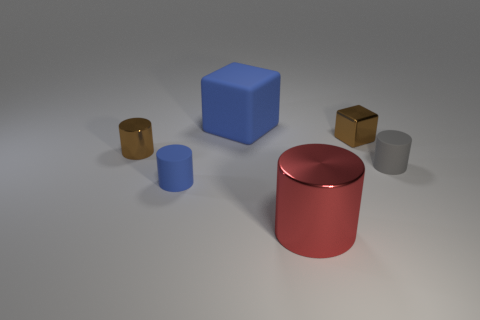There is a large thing that is behind the gray rubber cylinder; is it the same shape as the small blue rubber thing?
Keep it short and to the point. No. How many objects are either small purple rubber things or small brown objects?
Provide a succinct answer. 2. Do the small brown thing on the left side of the small metallic cube and the big blue block have the same material?
Provide a short and direct response. No. What is the size of the red shiny thing?
Make the answer very short. Large. What shape is the other matte object that is the same color as the big matte object?
Offer a very short reply. Cylinder. How many cylinders are either small blue matte objects or tiny objects?
Offer a terse response. 3. Are there the same number of tiny brown things in front of the gray thing and small metallic objects that are on the right side of the big metal cylinder?
Provide a succinct answer. No. What size is the blue rubber object that is the same shape as the gray thing?
Ensure brevity in your answer.  Small. How big is the cylinder that is to the right of the big blue block and behind the red metallic cylinder?
Your answer should be very brief. Small. Are there any objects right of the gray matte cylinder?
Offer a terse response. No. 